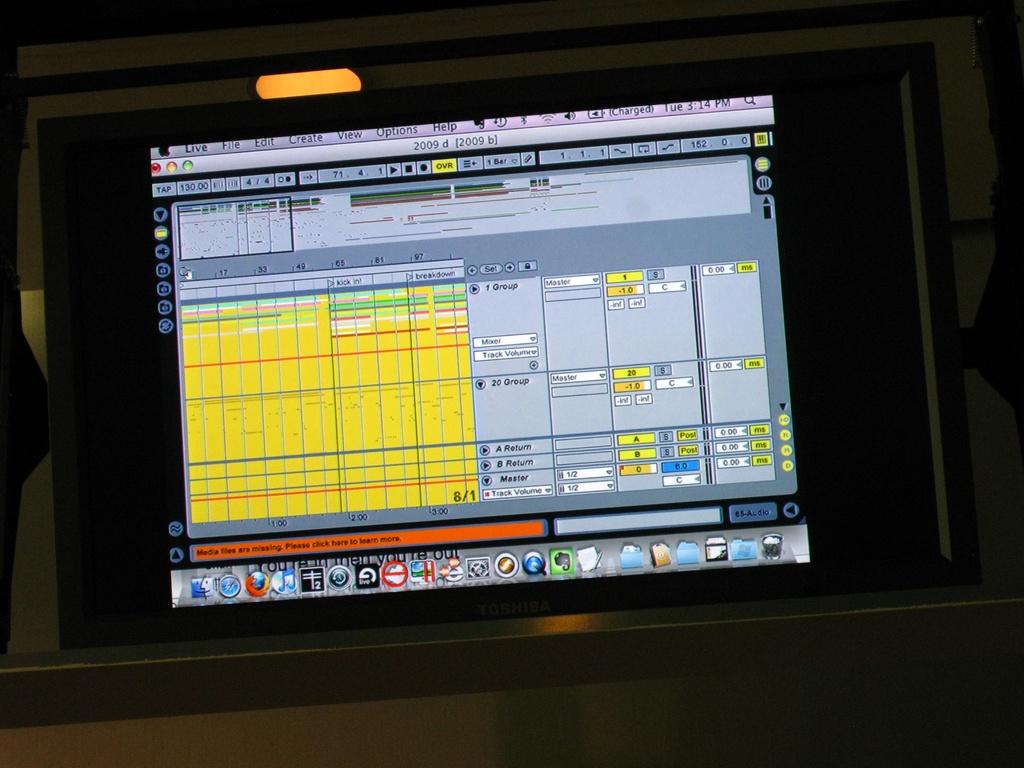What is the time on this computer?
Provide a short and direct response. 3:14 pm. What is the day mentioned on the computer?
Ensure brevity in your answer.  Tuesday. 